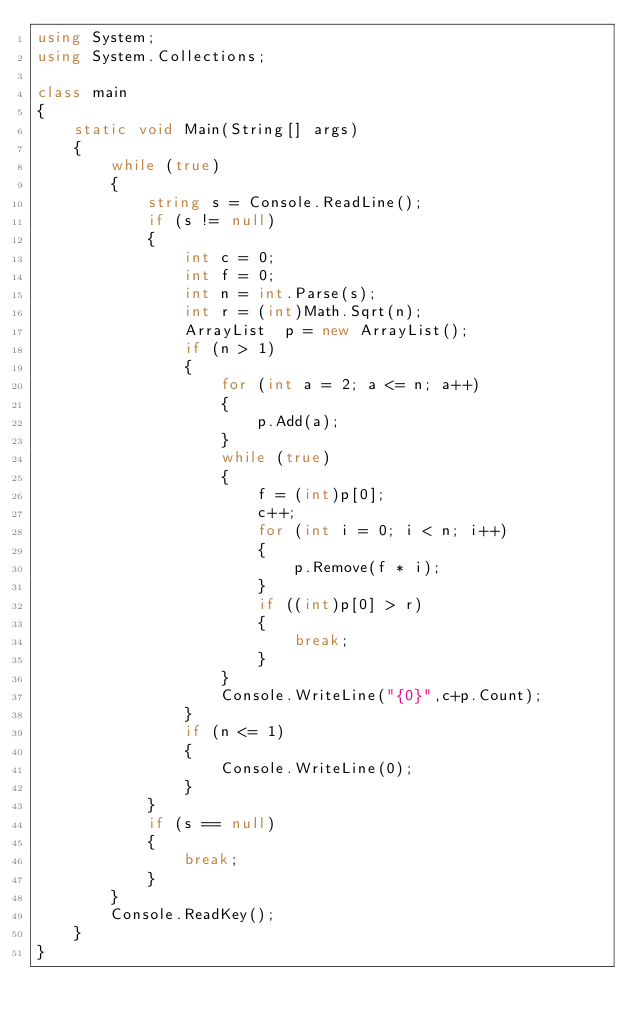Convert code to text. <code><loc_0><loc_0><loc_500><loc_500><_C#_>using System;
using System.Collections;

class main
{
    static void Main(String[] args)
    {
        while (true)
        {
            string s = Console.ReadLine();           
            if (s != null)
            {
                int c = 0;
                int f = 0;
                int n = int.Parse(s);
                int r = (int)Math.Sqrt(n);
                ArrayList  p = new ArrayList();
                if (n > 1)
                {
                    for (int a = 2; a <= n; a++)
                    {
                        p.Add(a);
                    }
                    while (true)
                    {
                        f = (int)p[0];
                        c++;
                        for (int i = 0; i < n; i++)
                        {
                            p.Remove(f * i);
                        }
                        if ((int)p[0] > r)
                        {
                            break;
                        }
                    }
                    Console.WriteLine("{0}",c+p.Count);
                }
                if (n <= 1)
                {
                    Console.WriteLine(0);
                }
            }
            if (s == null)
            {
                break;
            }
        }
        Console.ReadKey();
    }
}</code> 